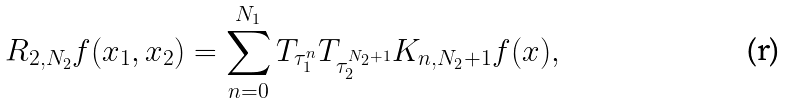Convert formula to latex. <formula><loc_0><loc_0><loc_500><loc_500>R _ { 2 , N _ { 2 } } f ( x _ { 1 } , x _ { 2 } ) = \sum _ { n = 0 } ^ { N _ { 1 } } T _ { \tau _ { 1 } ^ { n } } T _ { \tau _ { 2 } ^ { N _ { 2 } + 1 } } K _ { n , N _ { 2 } + 1 } f ( x ) ,</formula> 